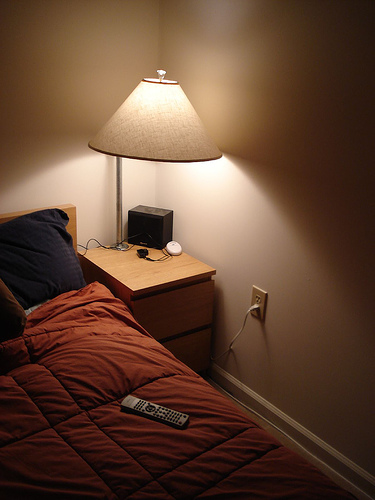<image>
Can you confirm if the remote is on the bed? Yes. Looking at the image, I can see the remote is positioned on top of the bed, with the bed providing support. Is the plug in the socket? Yes. The plug is contained within or inside the socket, showing a containment relationship. 